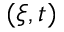<formula> <loc_0><loc_0><loc_500><loc_500>( \xi , t )</formula> 